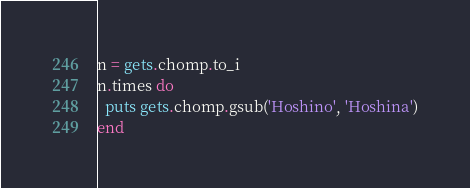Convert code to text. <code><loc_0><loc_0><loc_500><loc_500><_Ruby_>n = gets.chomp.to_i
n.times do
  puts gets.chomp.gsub('Hoshino', 'Hoshina')
end</code> 